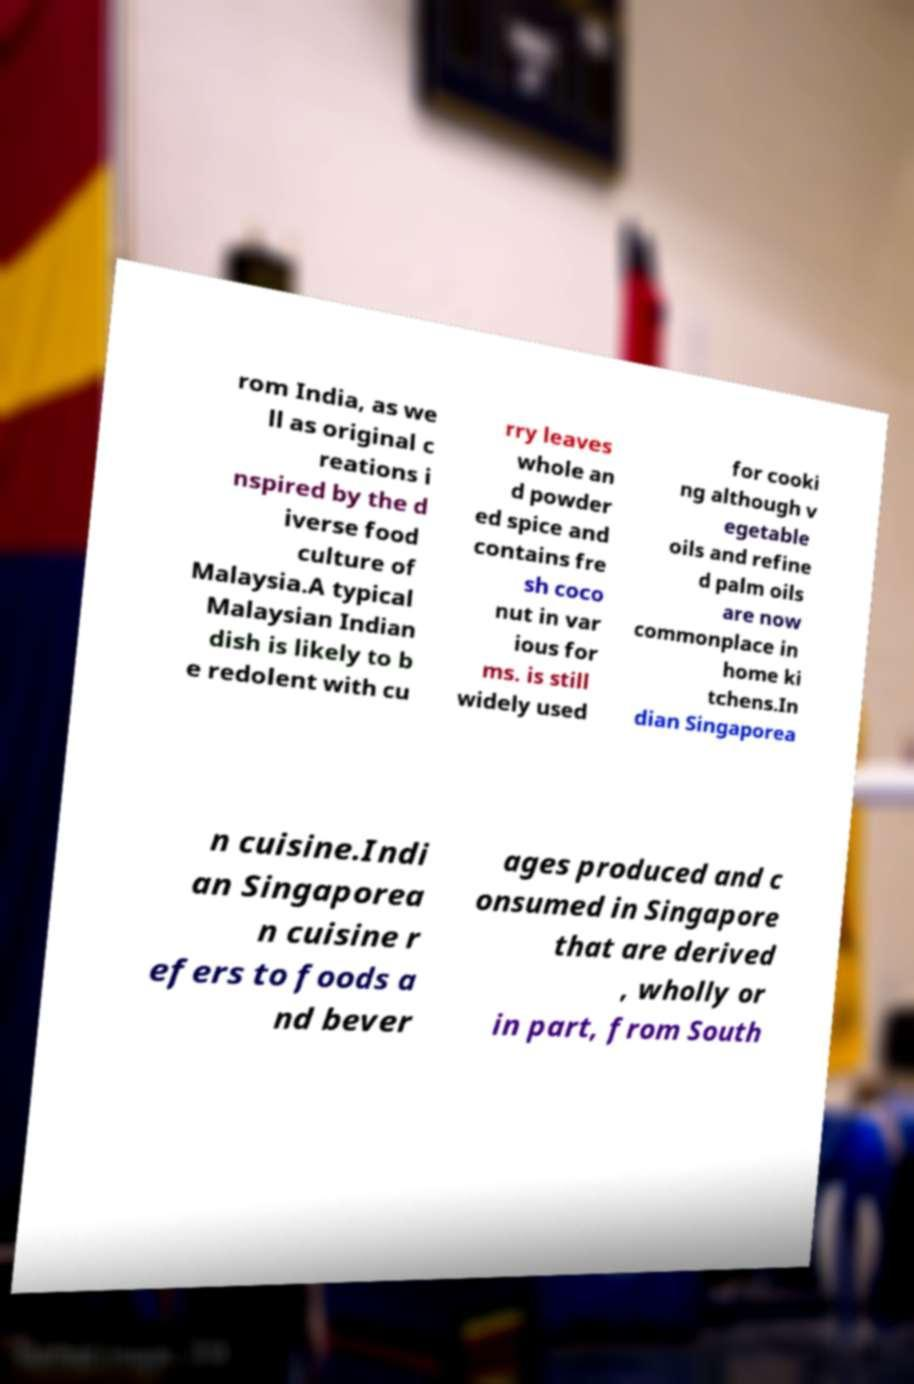For documentation purposes, I need the text within this image transcribed. Could you provide that? rom India, as we ll as original c reations i nspired by the d iverse food culture of Malaysia.A typical Malaysian Indian dish is likely to b e redolent with cu rry leaves whole an d powder ed spice and contains fre sh coco nut in var ious for ms. is still widely used for cooki ng although v egetable oils and refine d palm oils are now commonplace in home ki tchens.In dian Singaporea n cuisine.Indi an Singaporea n cuisine r efers to foods a nd bever ages produced and c onsumed in Singapore that are derived , wholly or in part, from South 